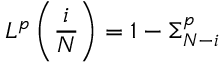<formula> <loc_0><loc_0><loc_500><loc_500>L ^ { p } \left ( \frac { i } { N } \right ) = 1 - \Sigma _ { N - i } ^ { p }</formula> 